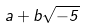<formula> <loc_0><loc_0><loc_500><loc_500>a + b \sqrt { - 5 }</formula> 